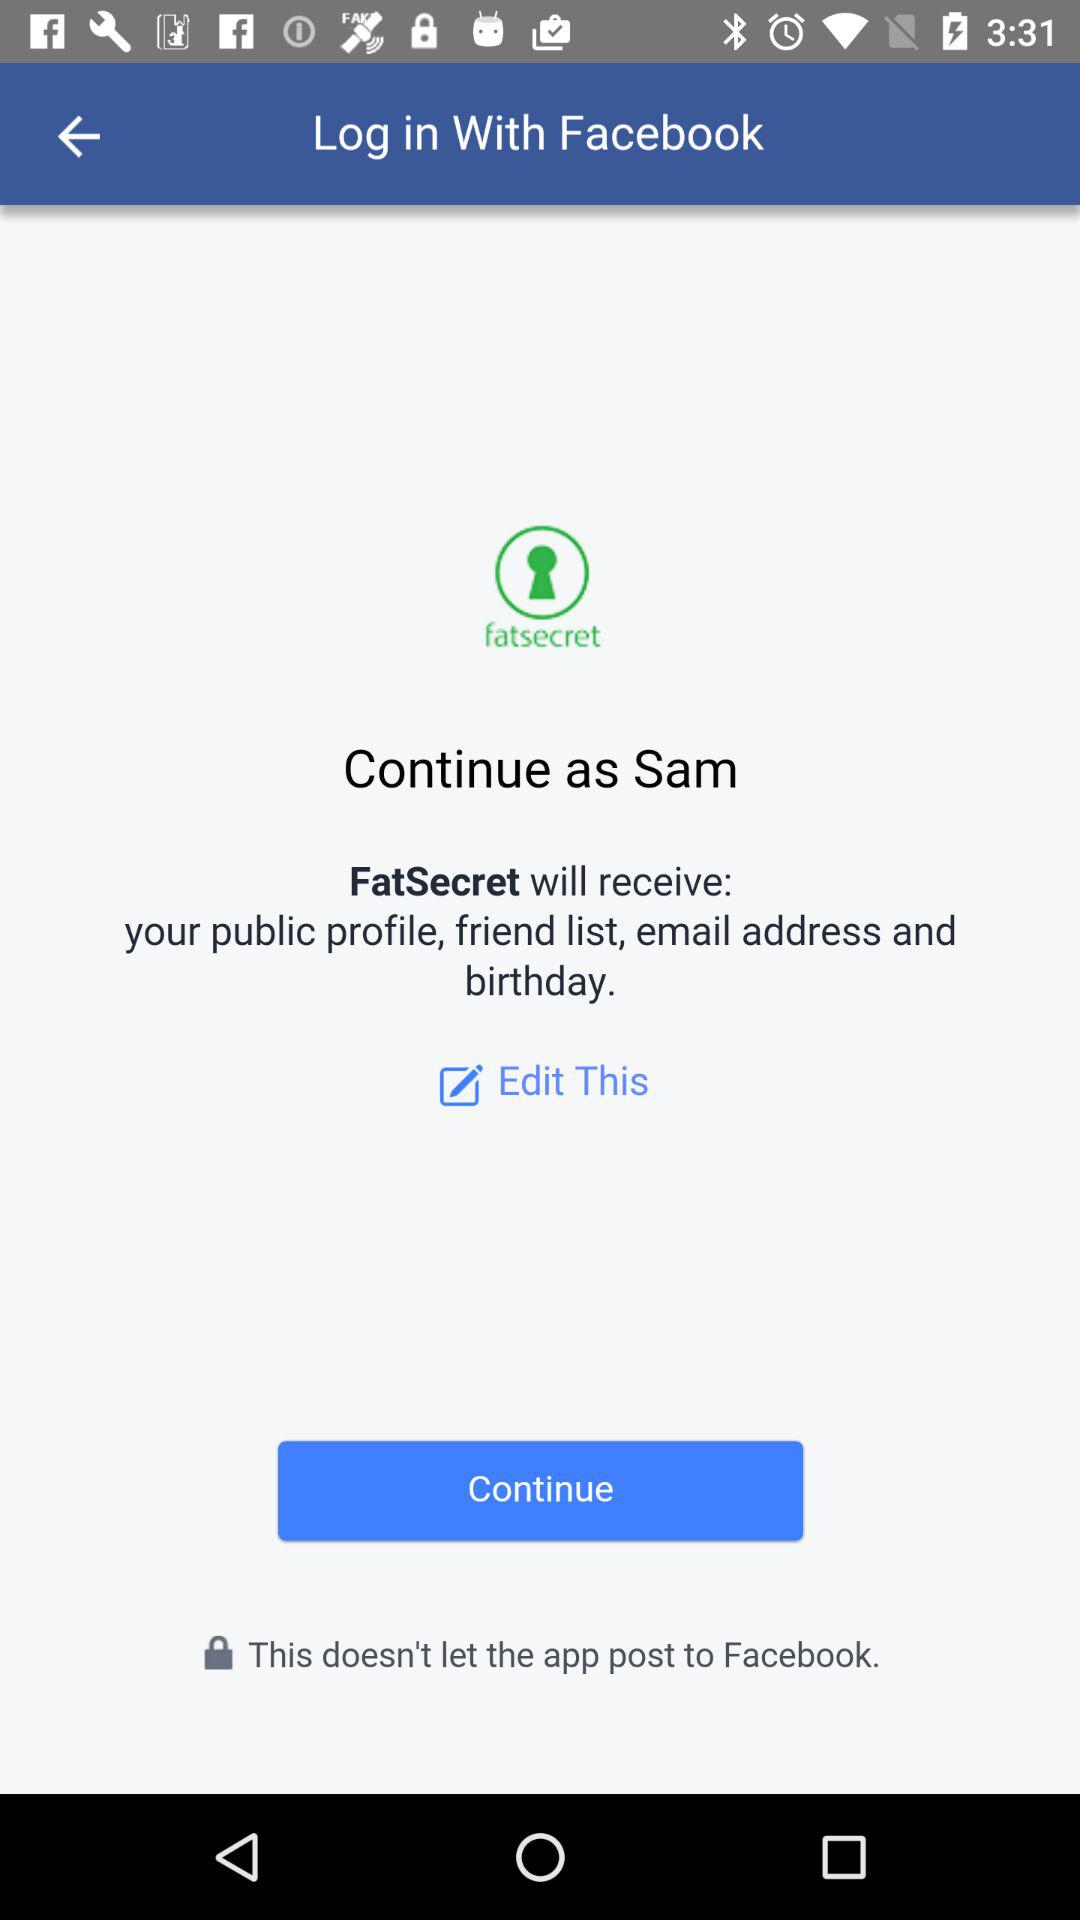What is the name of the user? The name of the user is "Sam". 